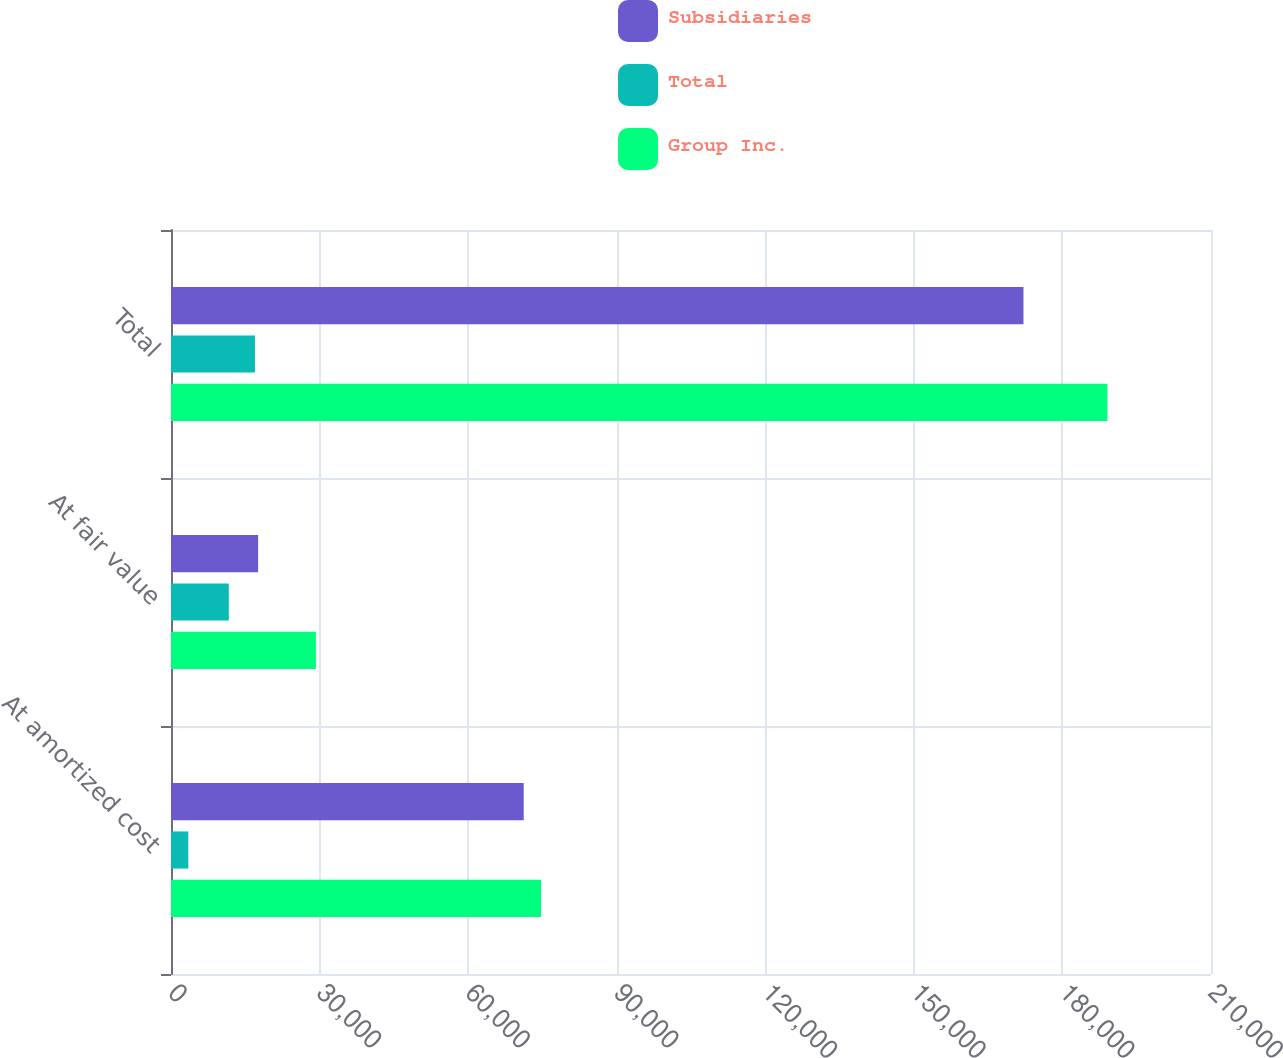<chart> <loc_0><loc_0><loc_500><loc_500><stacked_bar_chart><ecel><fcel>At amortized cost<fcel>At fair value<fcel>Total<nl><fcel>Subsidiaries<fcel>71225<fcel>17591<fcel>172135<nl><fcel>Total<fcel>3493<fcel>11669<fcel>16951<nl><fcel>Group Inc.<fcel>74718<fcel>29260<fcel>189086<nl></chart> 